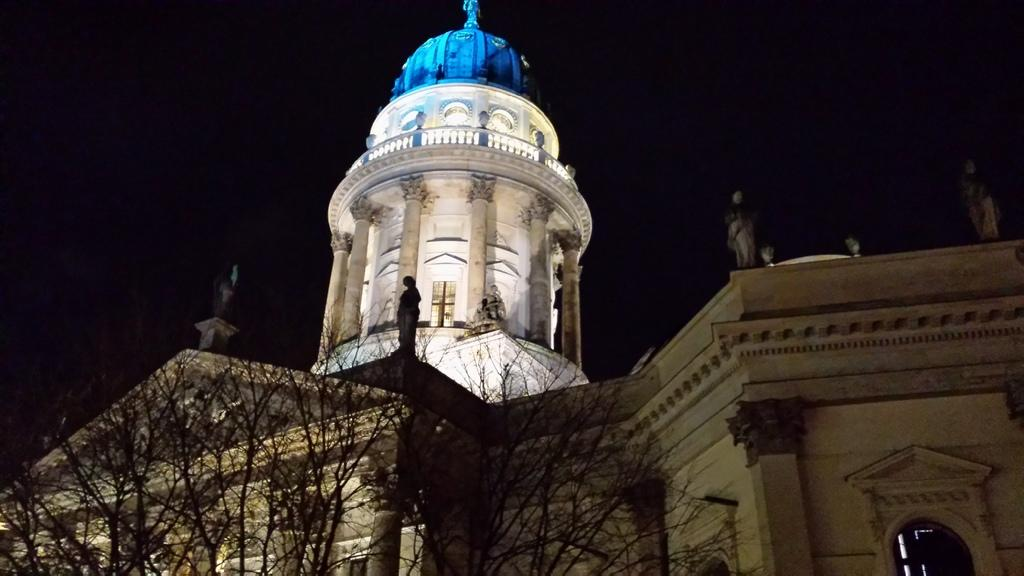What is the lighting condition in the image? The image was taken in the dark. What is the main structure in the image? There is a building in the image. What decorative elements are present on the building? There are statues on the walls of the building. What type of vegetation is at the bottom of the image? There are trees at the bottom of the image. What color is the background of the image? The background of the image is black. What type of fruit is hanging from the trees in the image? There is no fruit visible in the image; only trees are present at the bottom. What is being served for dinner in the image? There is no dinner or food being served in the image; it features a building with statues and trees. 